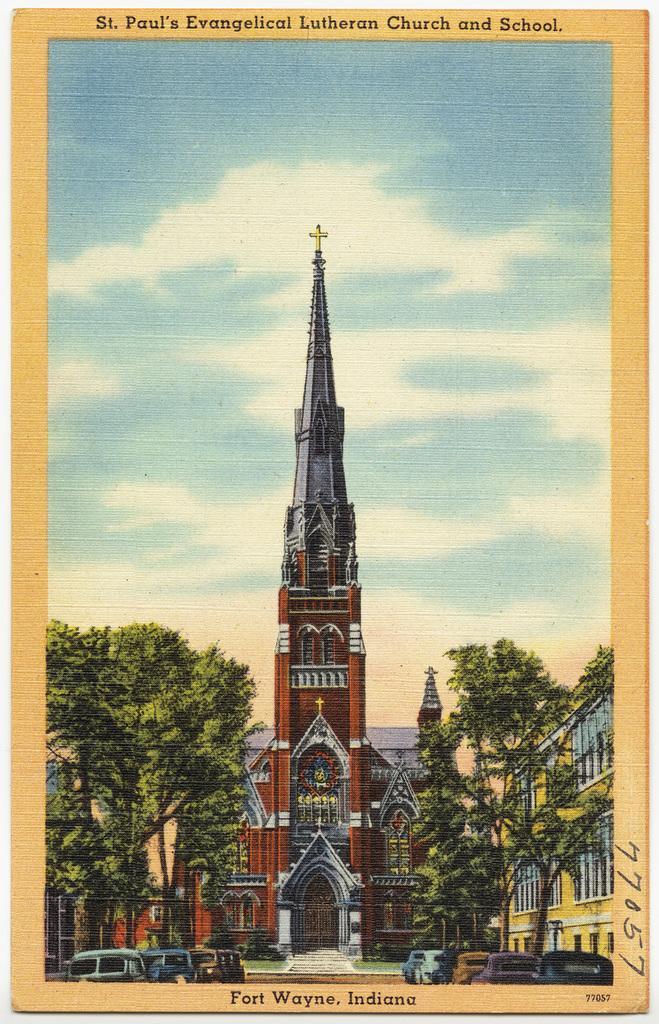Can you describe this image briefly? In this image we can see a painting. In the center of the image there is a building. On the right and left side of the image we can see buildings, cars and trees. In the background there are clouds and sky. 